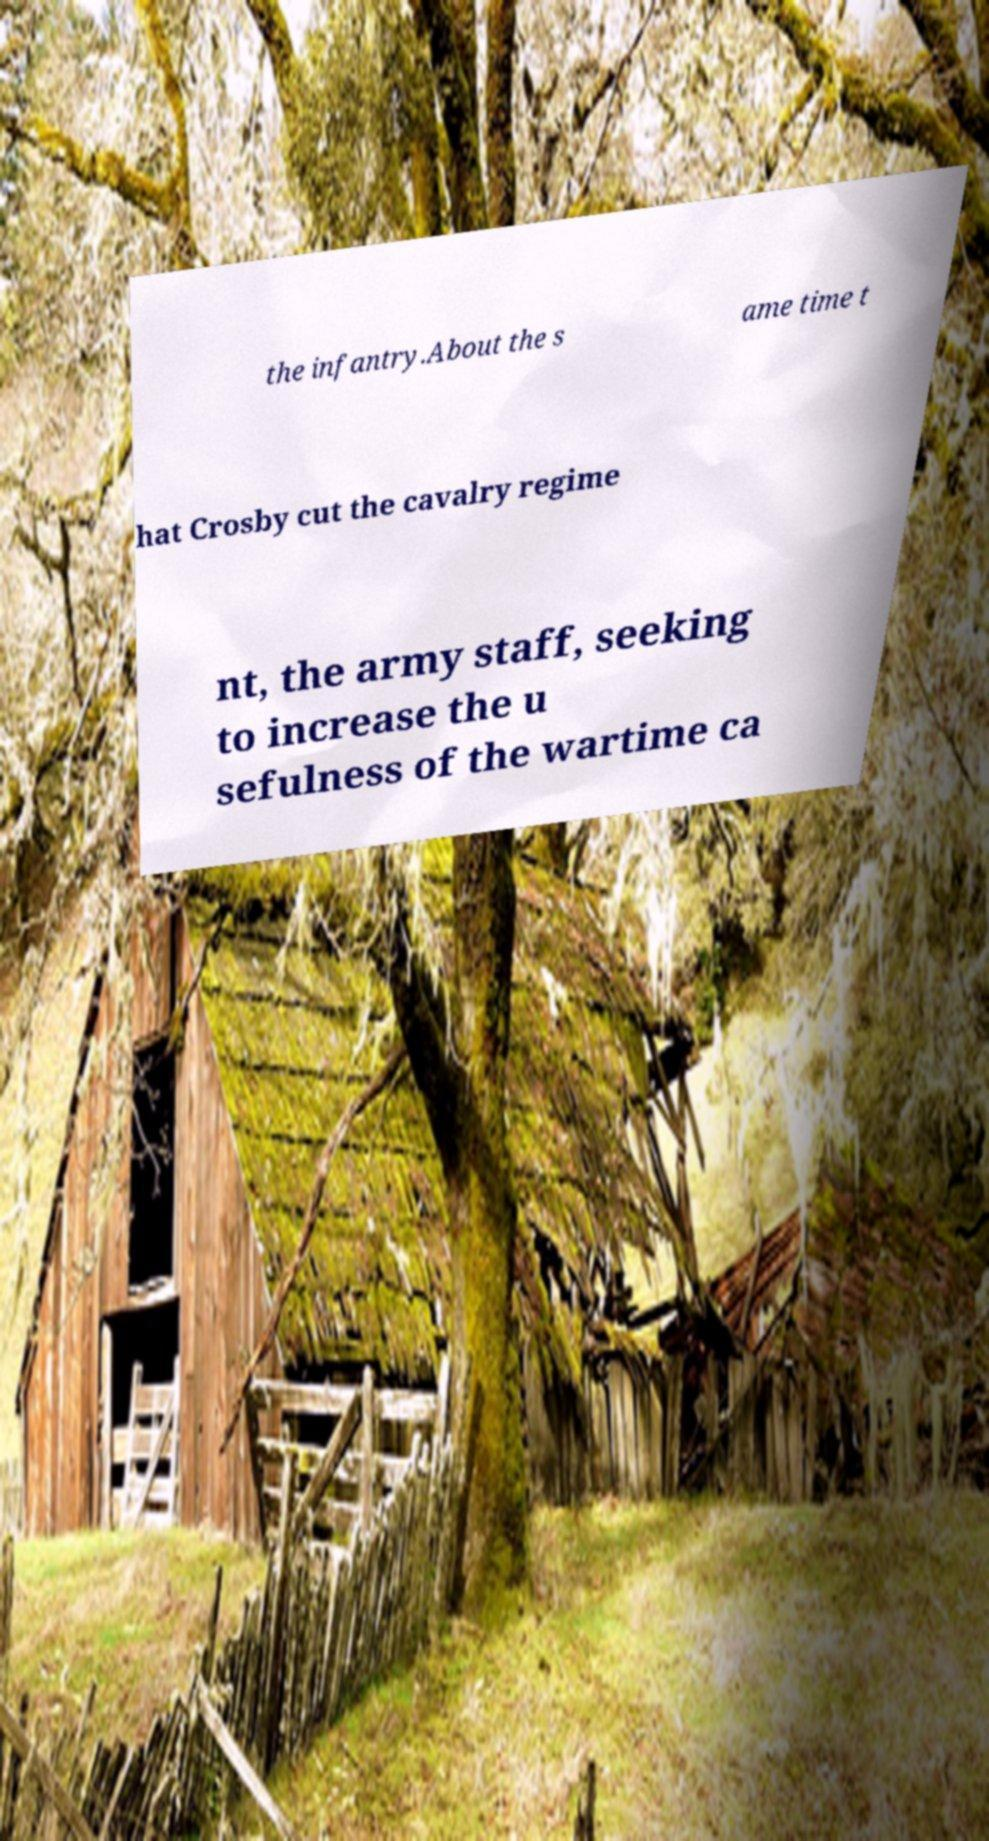I need the written content from this picture converted into text. Can you do that? the infantry.About the s ame time t hat Crosby cut the cavalry regime nt, the army staff, seeking to increase the u sefulness of the wartime ca 